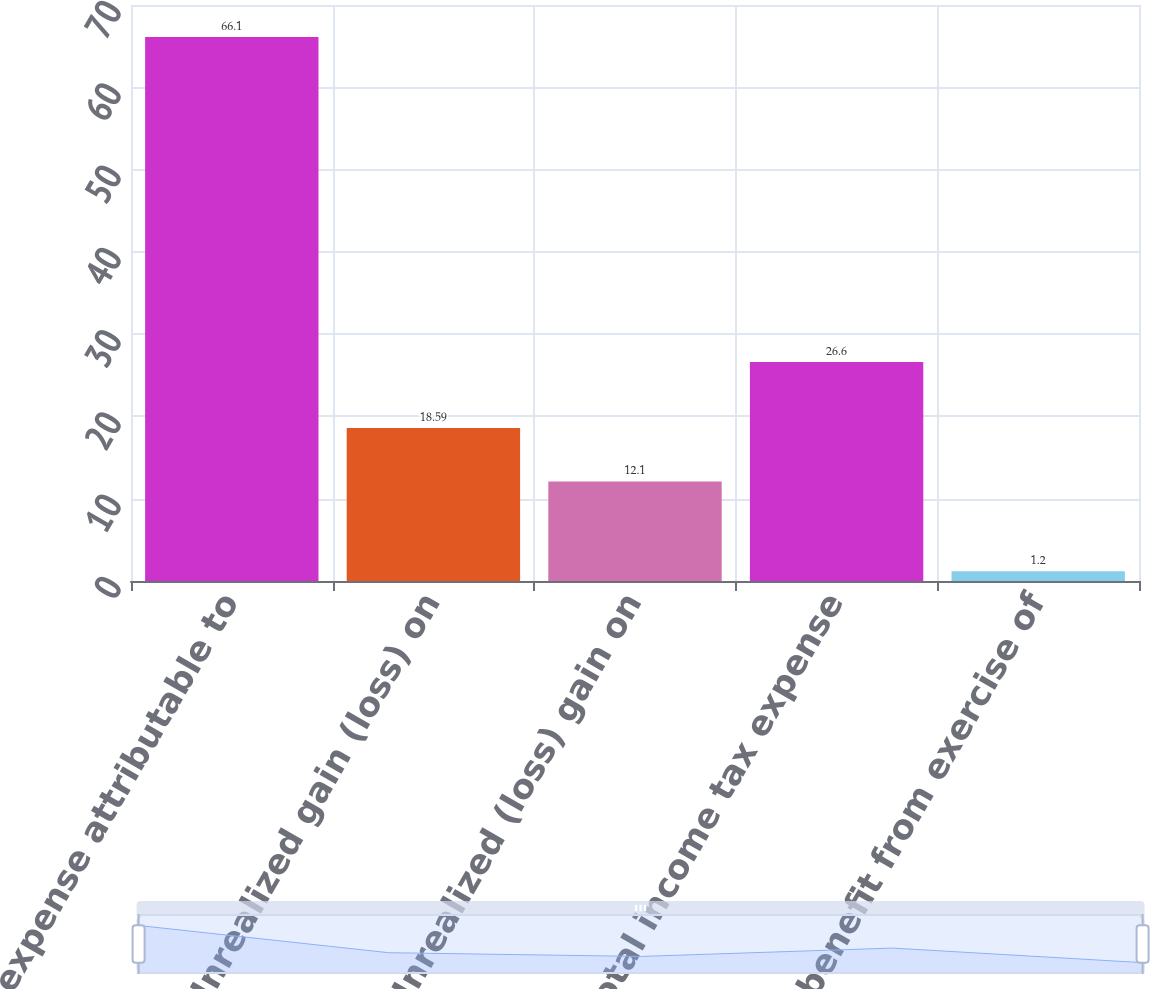<chart> <loc_0><loc_0><loc_500><loc_500><bar_chart><fcel>Tax expense attributable to<fcel>Unrealized gain (loss) on<fcel>Unrealized (loss) gain on<fcel>Total income tax expense<fcel>Tax benefit from exercise of<nl><fcel>66.1<fcel>18.59<fcel>12.1<fcel>26.6<fcel>1.2<nl></chart> 